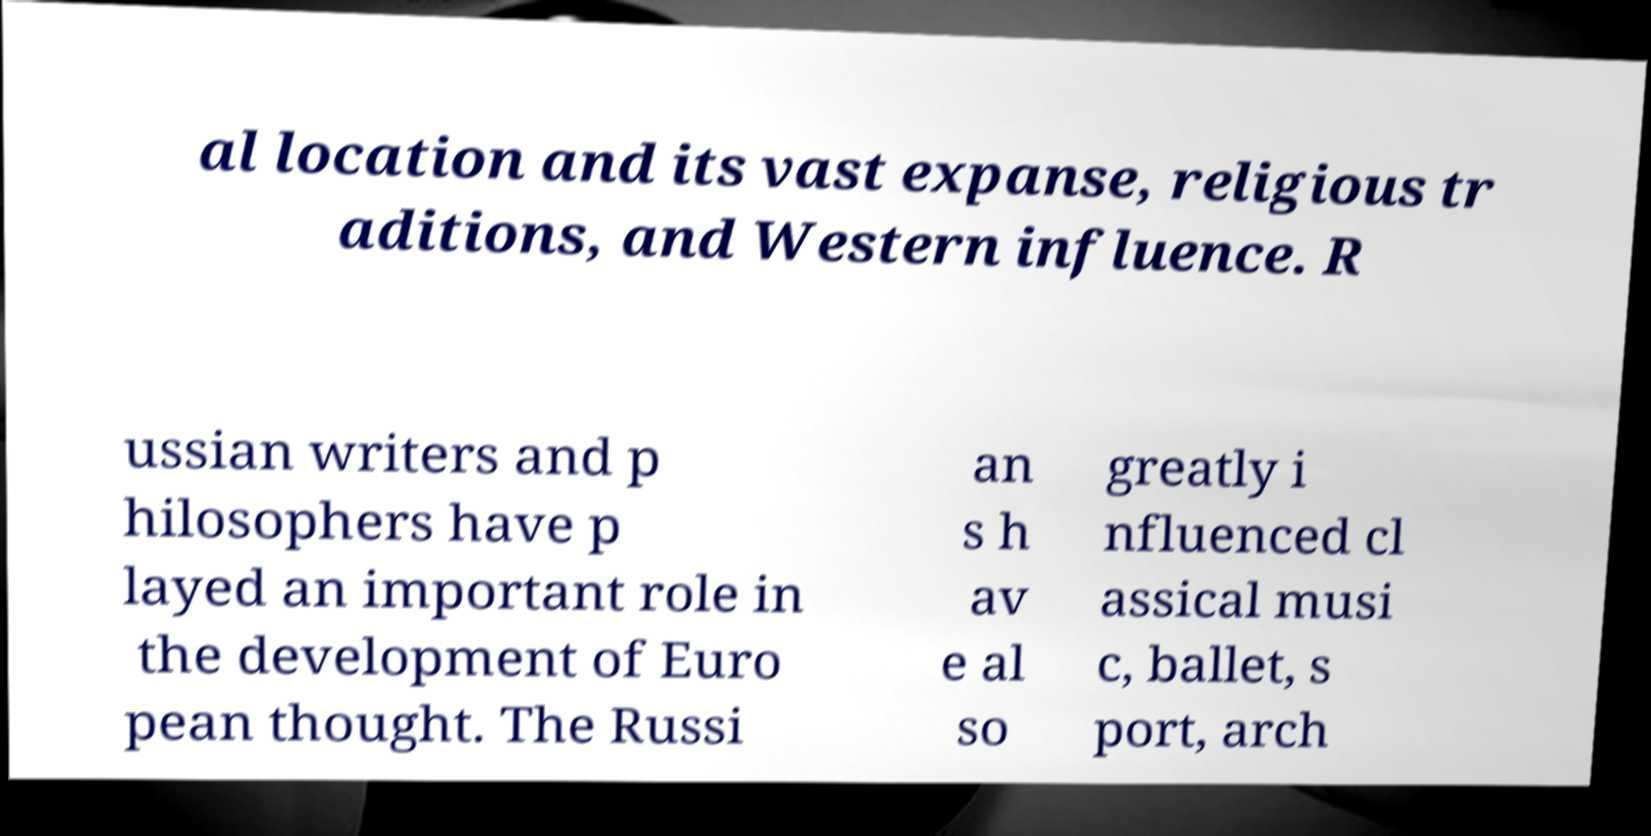Can you read and provide the text displayed in the image?This photo seems to have some interesting text. Can you extract and type it out for me? al location and its vast expanse, religious tr aditions, and Western influence. R ussian writers and p hilosophers have p layed an important role in the development of Euro pean thought. The Russi an s h av e al so greatly i nfluenced cl assical musi c, ballet, s port, arch 